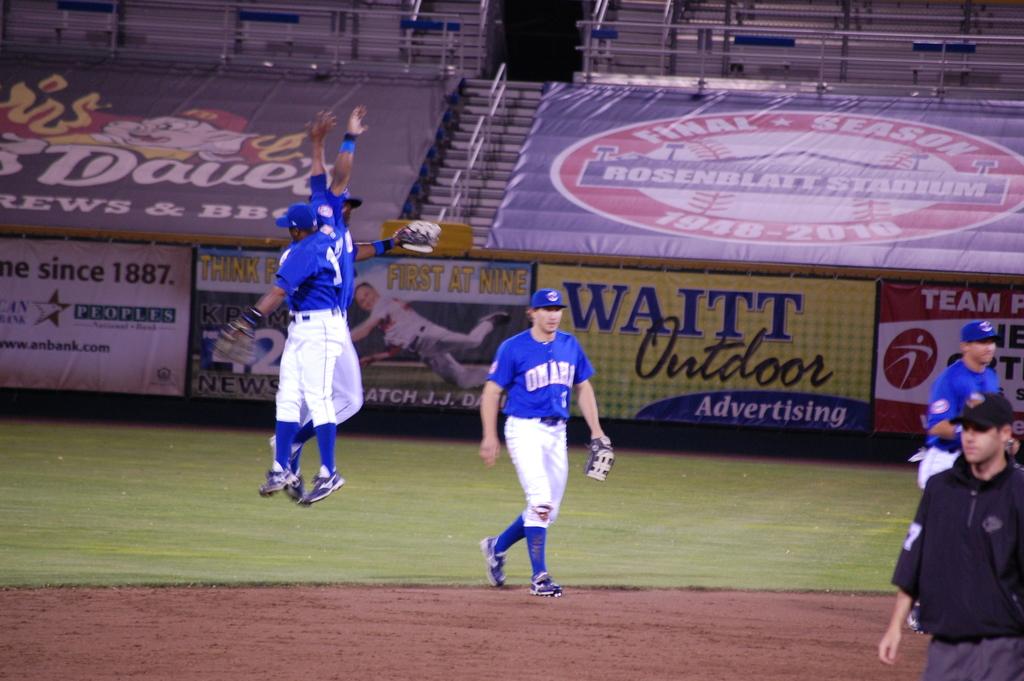What year is shown on the left?
Offer a very short reply. 1887. Name a company advertising on the wall?
Offer a very short reply. Waitt outdoor. 